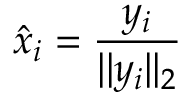Convert formula to latex. <formula><loc_0><loc_0><loc_500><loc_500>\hat { x } _ { i } = \frac { y _ { i } } { | | y _ { i } | | _ { 2 } }</formula> 